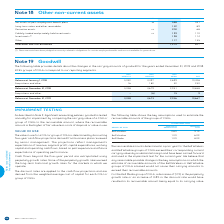According to Bce's financial document, What have the amounts for other non-current assets investments been pledged as? security related to obligations for certain employee benefits and are not available for general use. The document states: "(1) These amounts have been pledged as security related to obligations for certain employee benefits and are not available for general use...." Also, What is the amount of Investments in 2019? According to the financial document, 128. The relevant text states: "Investments (1) 128 114..." Also, What is the amount of Derivative assets in 2018? According to the financial document, 68. The relevant text states: "Derivative assets 26 200 68..." Also, can you calculate: What is the percentage change in net assets of post-employment benefit plans in 2019? To answer this question, I need to perform calculations using the financial data. The calculation is: (558-331)/331, which equals 68.58 (percentage). This is based on the information: "et assets of post-employment benefit plans 24 558 331 Net assets of post-employment benefit plans 24 558 331..." The key data points involved are: 331, 558. Also, can you calculate: What is the change in net assets of post-employment benefit plans in 2019? Based on the calculation: 558-331, the result is 227. This is based on the information: "et assets of post-employment benefit plans 24 558 331 Net assets of post-employment benefit plans 24 558 331..." The key data points involved are: 331, 558. Also, can you calculate: What is the change in the total other non-current assets in 2019?  Based on the calculation: 1,274-847, the result is 427. This is based on the information: "Total other non-current assets 1,274 847 Total other non-current assets 1,274 847..." The key data points involved are: 1,274, 847. 